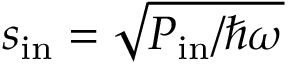<formula> <loc_0><loc_0><loc_500><loc_500>s _ { i n } = \sqrt { P _ { i n } / \hbar { \omega } }</formula> 